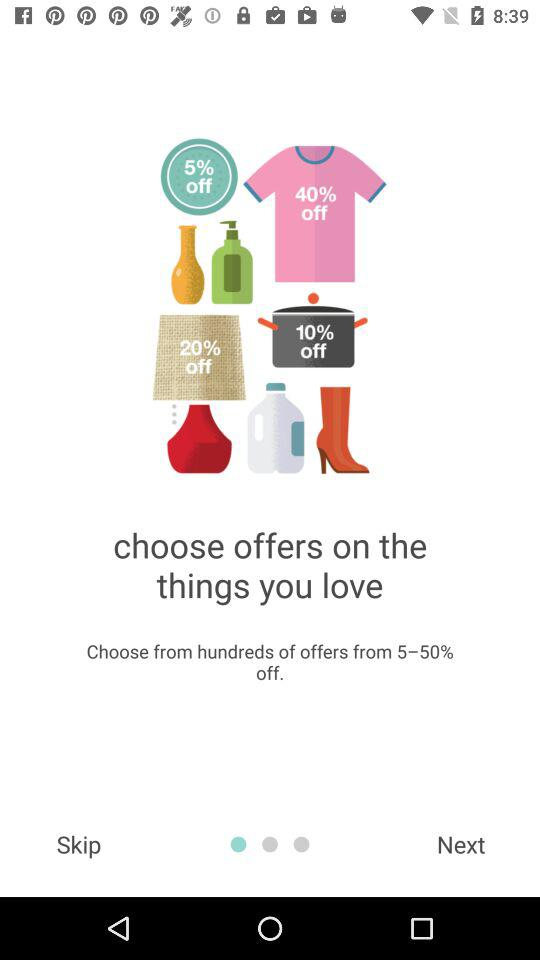How much off is given on hundreds of offers? The given off is 5 to 50 percent. 